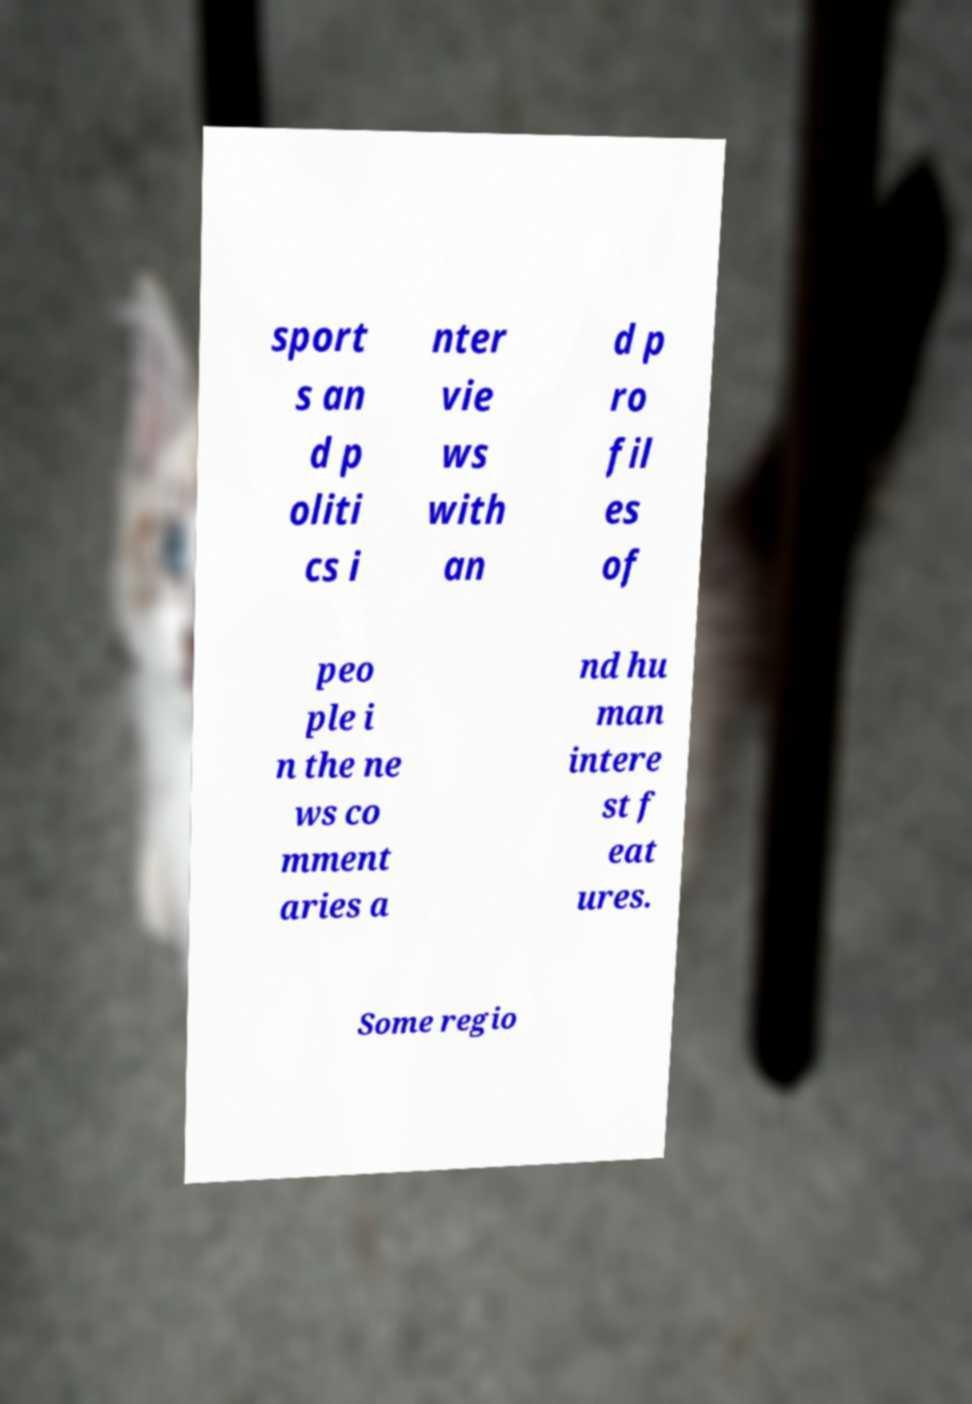Could you assist in decoding the text presented in this image and type it out clearly? sport s an d p oliti cs i nter vie ws with an d p ro fil es of peo ple i n the ne ws co mment aries a nd hu man intere st f eat ures. Some regio 